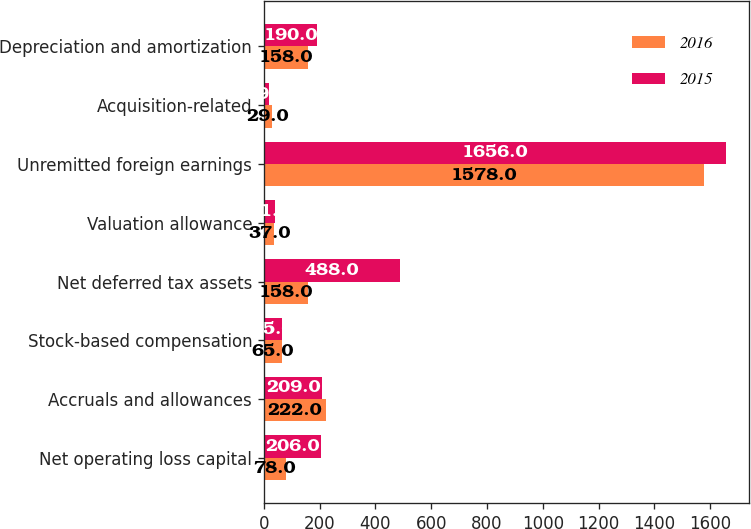<chart> <loc_0><loc_0><loc_500><loc_500><stacked_bar_chart><ecel><fcel>Net operating loss capital<fcel>Accruals and allowances<fcel>Stock-based compensation<fcel>Net deferred tax assets<fcel>Valuation allowance<fcel>Unremitted foreign earnings<fcel>Acquisition-related<fcel>Depreciation and amortization<nl><fcel>2016<fcel>78<fcel>222<fcel>65<fcel>158<fcel>37<fcel>1578<fcel>29<fcel>158<nl><fcel>2015<fcel>206<fcel>209<fcel>65<fcel>488<fcel>41<fcel>1656<fcel>19<fcel>190<nl></chart> 